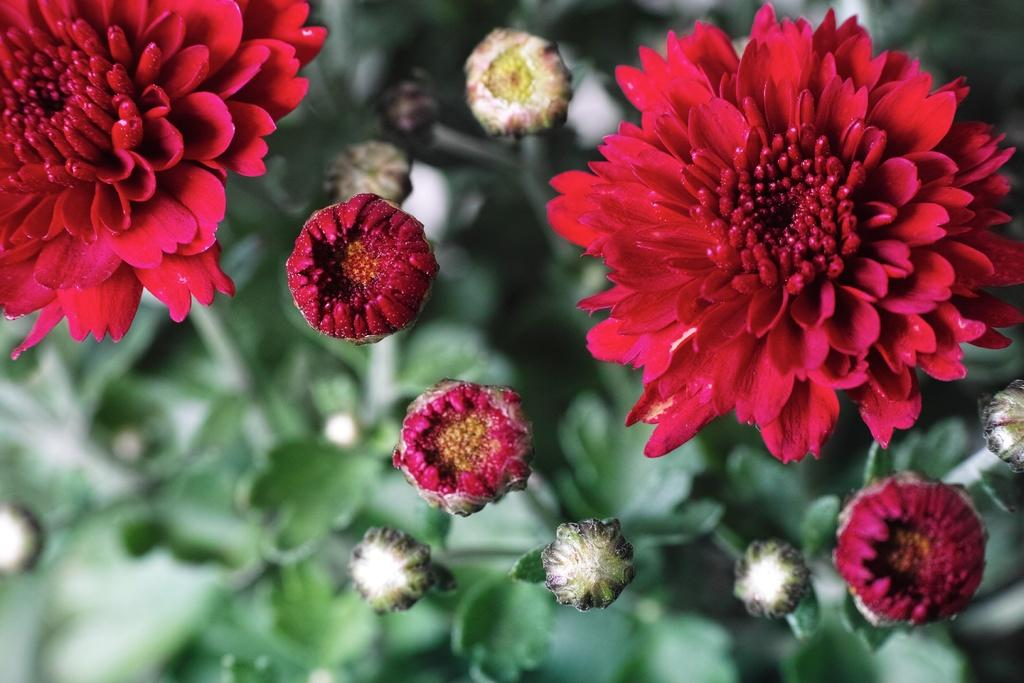What type of living organisms can be seen in the image? There are flowers in the image. Are the flowers attached to any specific type of plant? Yes, the flowers are on plants. What type of arch can be seen in the image? There is no arch present in the image; it features flowers on plants. What type of play is happening in the image? There is no play or any indication of a game in the image; it features flowers on plants. 